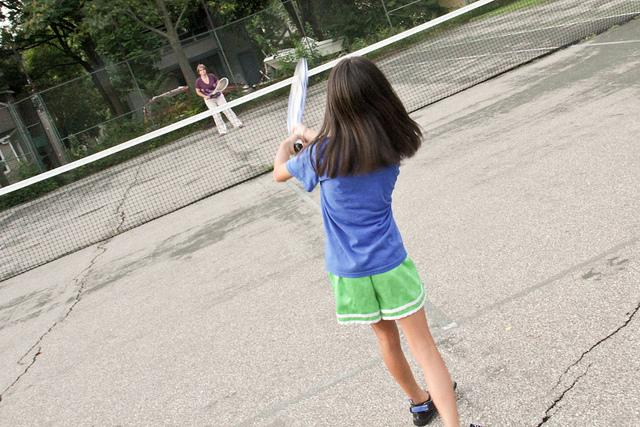Where does the girl want to hit the ball? Please explain your reasoning. over net. The girl is swinging her racket upwards, to strike a ball into the air. the rules of tennis call for balls to be hit over the net. 